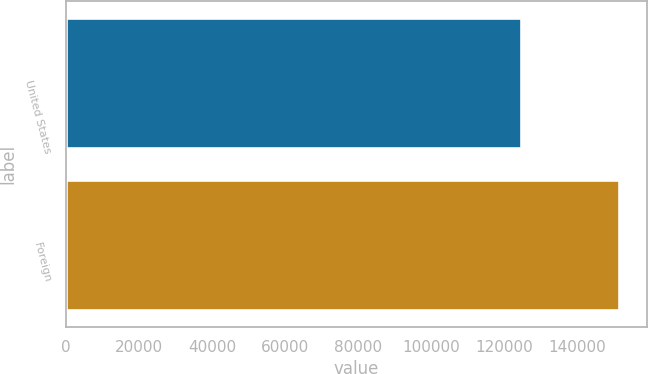Convert chart. <chart><loc_0><loc_0><loc_500><loc_500><bar_chart><fcel>United States<fcel>Foreign<nl><fcel>124500<fcel>151457<nl></chart> 